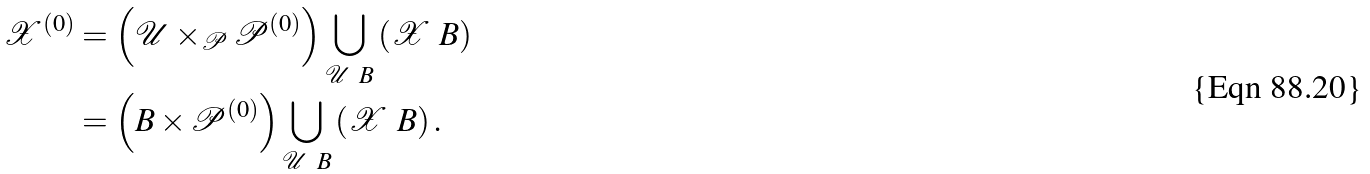<formula> <loc_0><loc_0><loc_500><loc_500>\mathcal { X } ^ { ( 0 ) } & = \left ( \mathcal { U } \times _ { \mathcal { P } } \mathcal { P } ^ { ( 0 ) } \right ) \bigcup _ { \mathcal { U } \ B } \left ( \mathcal { X } \ B \right ) \\ & = \left ( B \times \mathcal { P } ^ { ( 0 ) } \right ) \bigcup _ { \mathcal { U } \ B } \left ( \mathcal { X } \ B \right ) .</formula> 